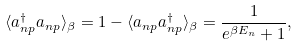<formula> <loc_0><loc_0><loc_500><loc_500>\langle a _ { n p } ^ { \dag } a _ { n p } \rangle _ { \beta } = 1 - \langle a _ { n p } a _ { n p } ^ { \dag } \rangle _ { \beta } = \frac { 1 } { e ^ { \beta E _ { n } } + 1 } ,</formula> 